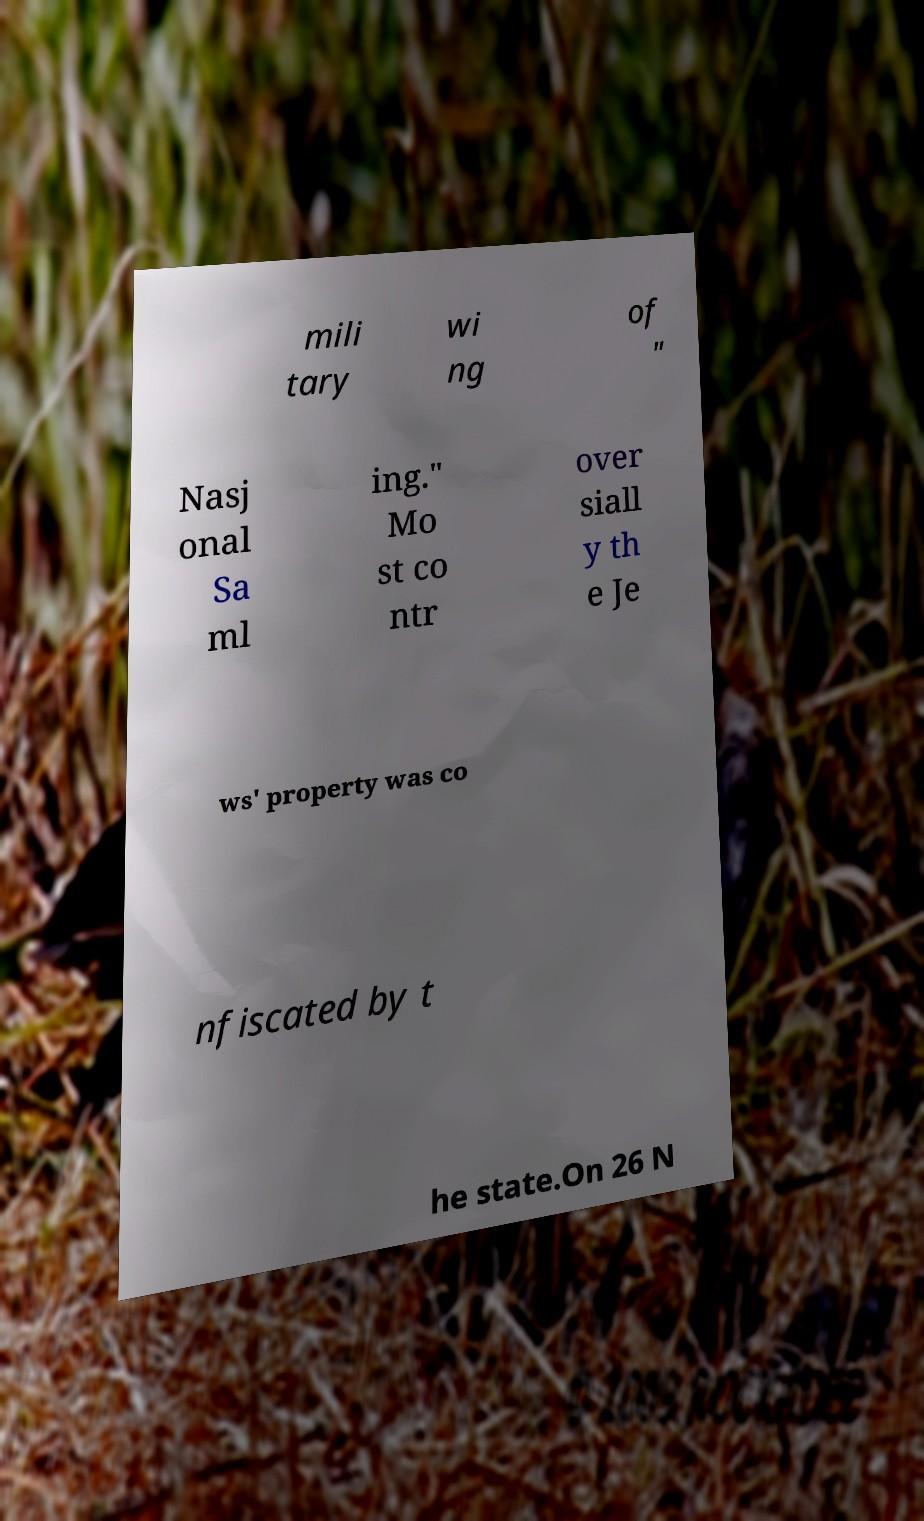For documentation purposes, I need the text within this image transcribed. Could you provide that? mili tary wi ng of " Nasj onal Sa ml ing." Mo st co ntr over siall y th e Je ws' property was co nfiscated by t he state.On 26 N 